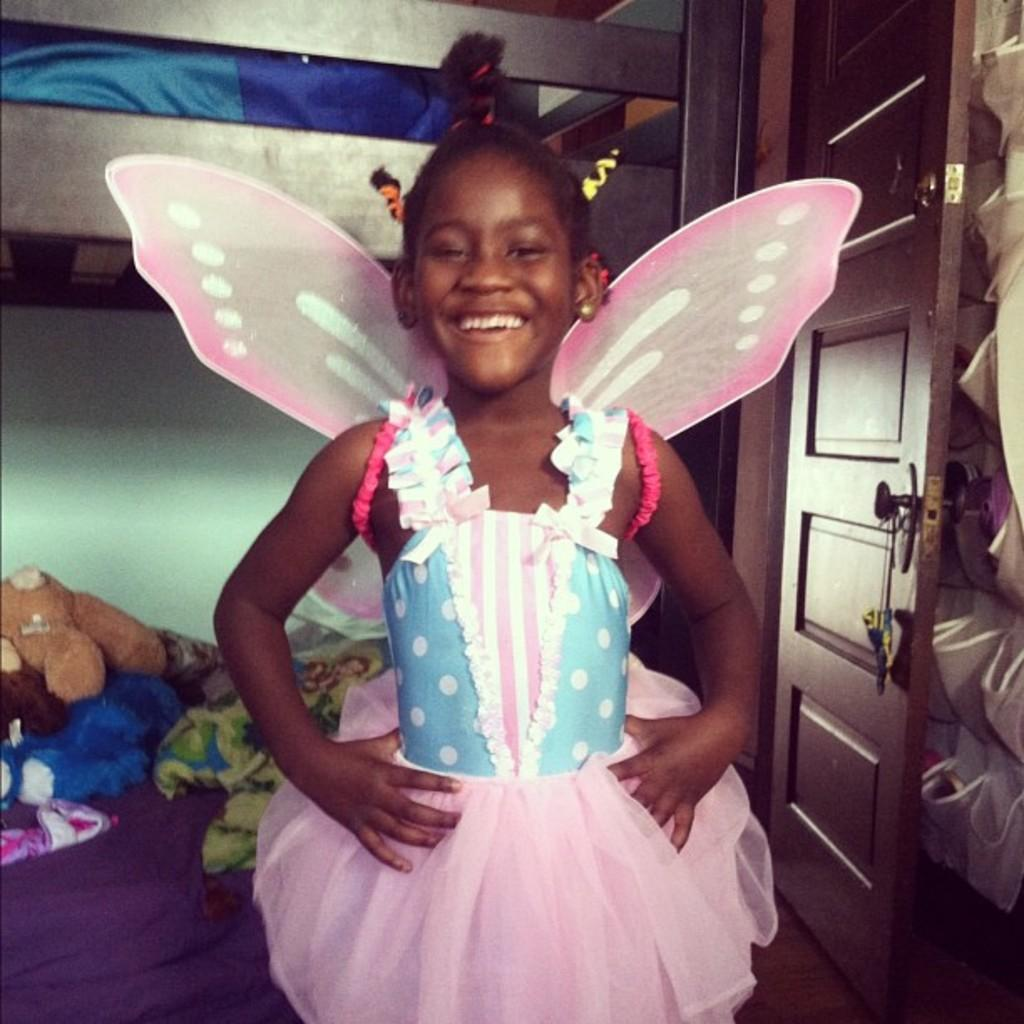What is the girl doing in the image? The girl is standing and smiling in the image. What can be seen in the background of the image? There is a door in the background of the image. Where are the toys located in the image? The toys are on the bed in the image. Can you describe any other items visible in the image? There are some items in the image, but their specific nature is not mentioned in the provided facts. What type of wool is the hen using to knit a scarf in the image? There is no hen or wool present in the image; it features a girl standing and smiling, with toys on the bed and a door in the background. 